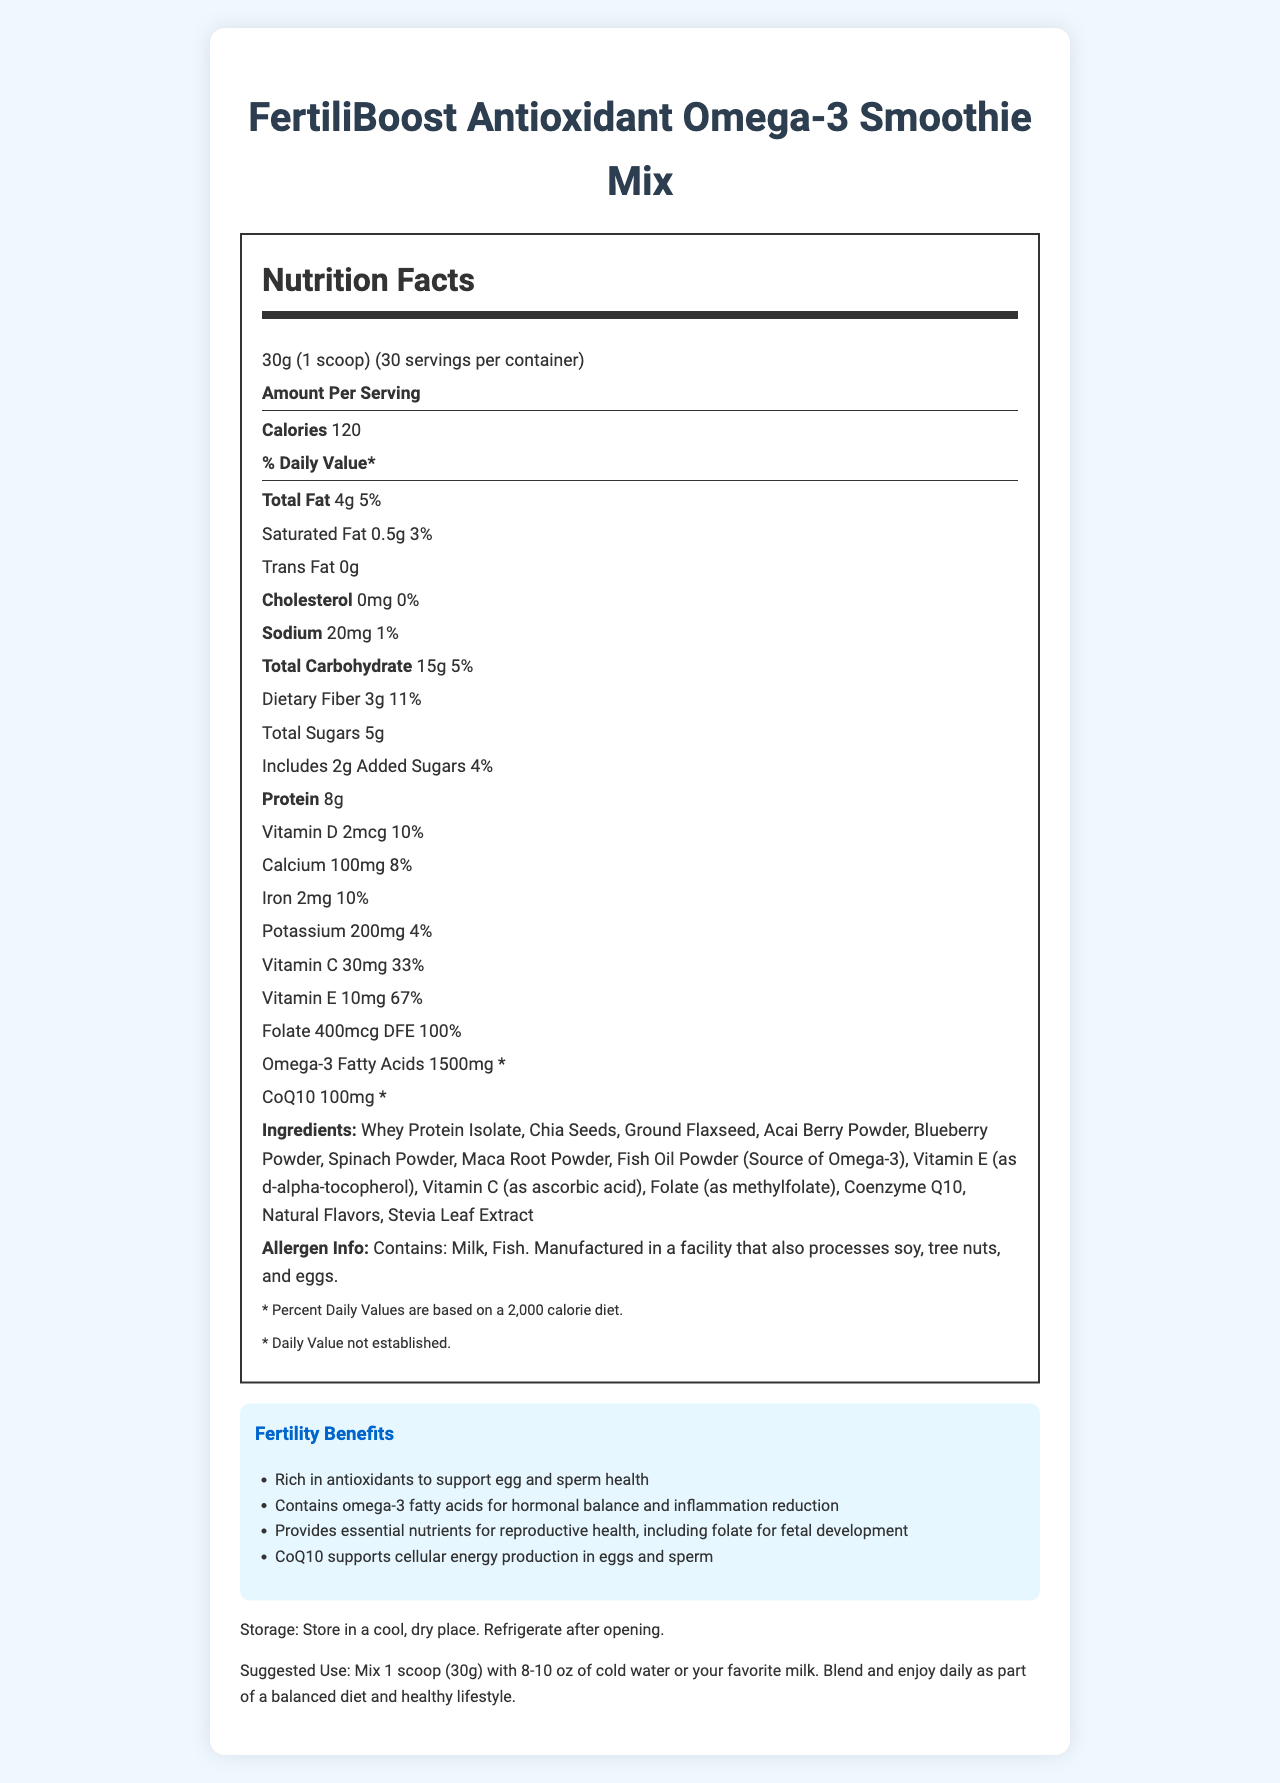What is the serving size for the FertiliBoost Antioxidant Omega-3 Smoothie Mix? The serving size is listed as "30g (1 scoop)" in the document.
Answer: 30g (1 scoop) How many calories are there per serving of the smoothie mix? The document states that each serving contains 120 calories.
Answer: 120 Which ingredients in the smoothie mix are sources of omega-3 fatty acids? These ingredients are listed in the ingredients section and are known sources of omega-3 fatty acids.
Answer: Chia Seeds, Ground Flaxseed, Fish Oil Powder What percentage of the daily value of Vitamin C is provided per serving? The document mentions that each serving provides 30mg of Vitamin C, which is 33% of the daily value.
Answer: 33% What amount of folate is present in each serving of the smoothie mix? The folate content is listed as "400mcg DFE" on the document.
Answer: 400mcg DFE Which nutrient supports cellular energy production in eggs and sperm according to the document? The "fertility benefits" section states that CoQ10 supports cellular energy production in eggs and sperm.
Answer: Coenzyme Q10 What are the main allergens mentioned in the allergen info section? The allergen information section lists milk and fish as the main allergens.
Answer: Milk, Fish How many servings are there in one container of FertiliBoost Antioxidant Omega-3 Smoothie Mix? The document states that there are 30 servings per container.
Answer: 30 True or False: The smoothie mix contains added sugars. The document mentions that it includes 2g of added sugars.
Answer: True Which of the following is NOT a listed ingredient in the smoothie mix? A. Spinach Powder B. Spirulina Powder C. Acai Berry Powder D. Blueberry Powder Spirulina Powder is not listed in the ingredients section, whereas the other options are.
Answer: B What is the recommended daily use of this smoothie mix according to the document? The suggested use section of the document provides this recommendation.
Answer: Mix 1 scoop (30g) with 8-10 oz of cold water or your favorite milk. Blend and enjoy daily. Which vitamin has the highest daily value percentage per serving in this smoothie mix? A. Vitamin D B. Iron C. Vitamin C D. Folate Folate has 100% daily value per serving, which is the highest among the options listed.
Answer: D Summarize the primary nutritional and health benefits of the FertiliBoost Antioxidant Omega-3 Smoothie Mix. The document emphasizes antioxidants and omega-3 fatty acids for fertility, listing specific benefits and nutrients supporting reproductive health.
Answer: The smoothie mix is rich in antioxidants and omega-3 fatty acids to support fertility, including egg and sperm health. It provides essential nutrients like folate for fetal development and CoQ10 for cellular energy production. What is the total fat content per serving and its daily value percentage? The document mentions that each serving has 4g of total fat, which is 5% of the daily value.
Answer: 4g, 5% Where should the smoothie mix be stored after opening according to the document? The storage instructions specify that the mix should be refrigerated after opening.
Answer: Refrigerate after opening How much protein is present in each serving of the FertiliBoost Antioxidant Omega-3 Smoothie Mix? The document lists the protein content per serving as 8g.
Answer: 8g Does the document provide information on the percentage daily value of omega-3 fatty acids? The document includes a disclaimer stating that the daily value for omega-3 fatty acids has not been established.
Answer: No 